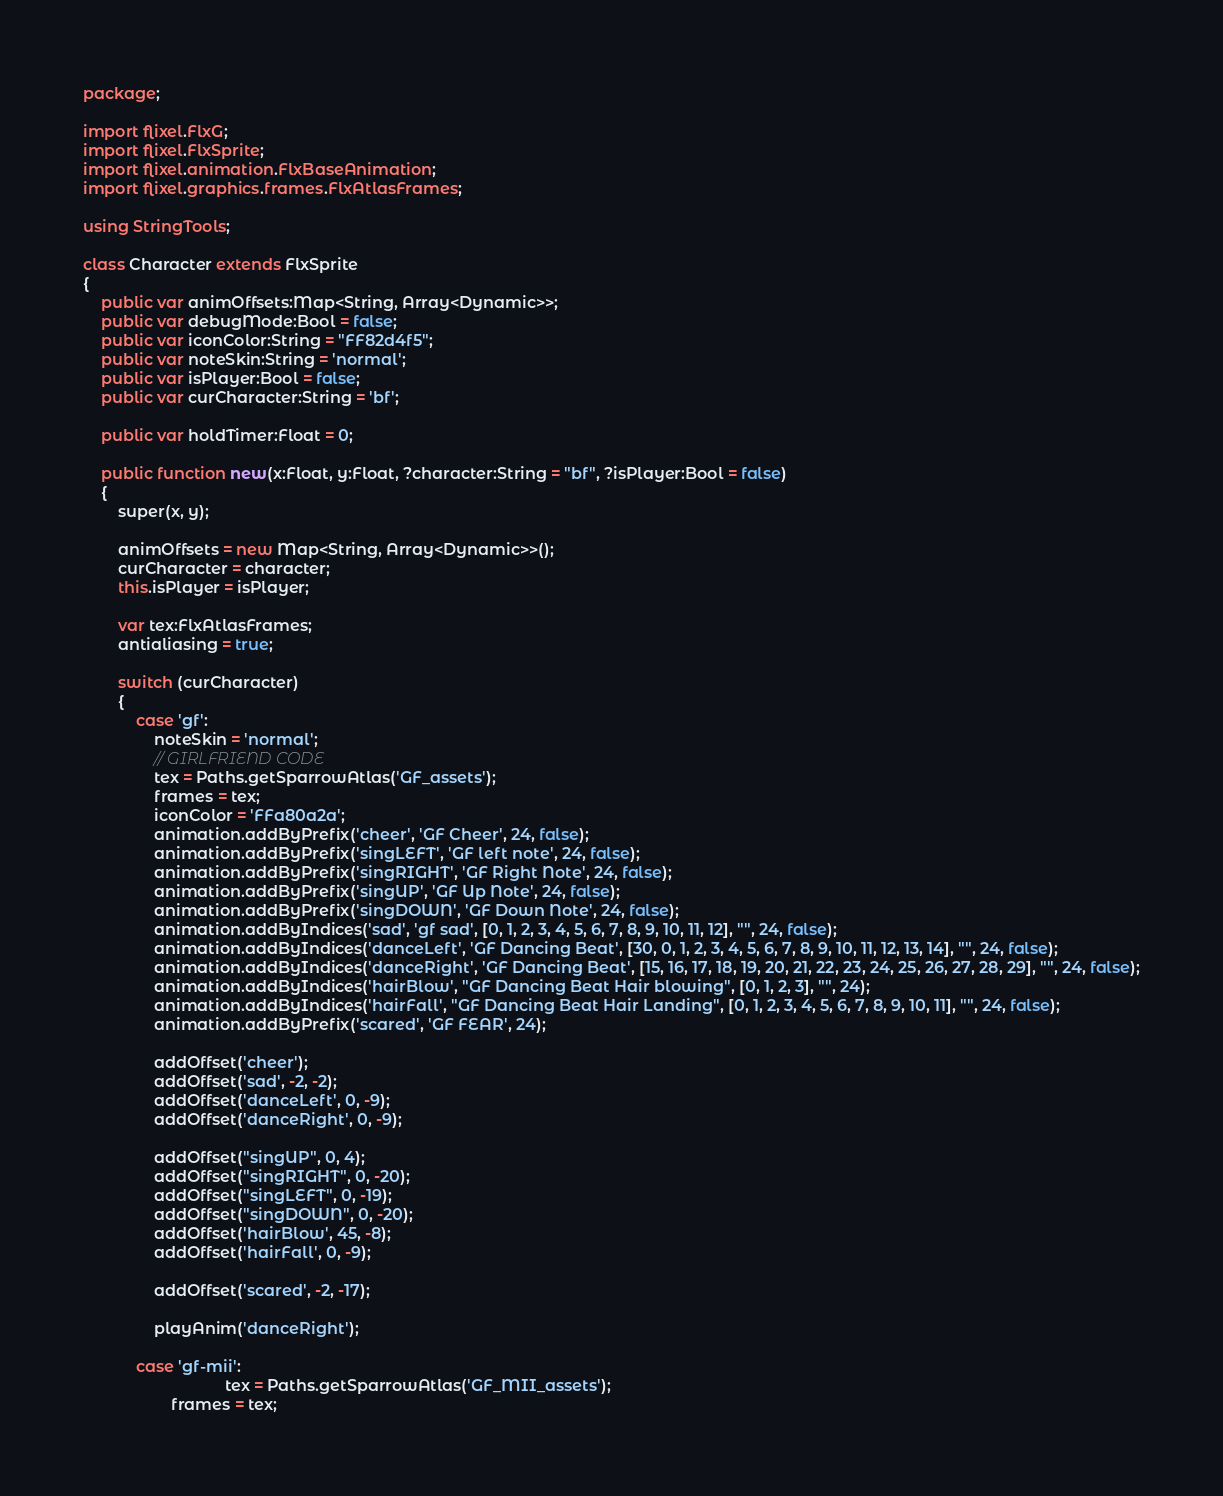<code> <loc_0><loc_0><loc_500><loc_500><_Haxe_>package;

import flixel.FlxG;
import flixel.FlxSprite;
import flixel.animation.FlxBaseAnimation;
import flixel.graphics.frames.FlxAtlasFrames;

using StringTools;

class Character extends FlxSprite
{
	public var animOffsets:Map<String, Array<Dynamic>>;
	public var debugMode:Bool = false;
	public var iconColor:String = "FF82d4f5";
	public var noteSkin:String = 'normal';
	public var isPlayer:Bool = false;
	public var curCharacter:String = 'bf';

	public var holdTimer:Float = 0;

	public function new(x:Float, y:Float, ?character:String = "bf", ?isPlayer:Bool = false)
	{
		super(x, y);

		animOffsets = new Map<String, Array<Dynamic>>();
		curCharacter = character;
		this.isPlayer = isPlayer;

		var tex:FlxAtlasFrames;
		antialiasing = true;

		switch (curCharacter)
		{
			case 'gf':
				noteSkin = 'normal';
				// GIRLFRIEND CODE
				tex = Paths.getSparrowAtlas('GF_assets');
				frames = tex;
				iconColor = 'FFa80a2a';
				animation.addByPrefix('cheer', 'GF Cheer', 24, false);
				animation.addByPrefix('singLEFT', 'GF left note', 24, false);
				animation.addByPrefix('singRIGHT', 'GF Right Note', 24, false);
				animation.addByPrefix('singUP', 'GF Up Note', 24, false);
				animation.addByPrefix('singDOWN', 'GF Down Note', 24, false);
				animation.addByIndices('sad', 'gf sad', [0, 1, 2, 3, 4, 5, 6, 7, 8, 9, 10, 11, 12], "", 24, false);
				animation.addByIndices('danceLeft', 'GF Dancing Beat', [30, 0, 1, 2, 3, 4, 5, 6, 7, 8, 9, 10, 11, 12, 13, 14], "", 24, false);
				animation.addByIndices('danceRight', 'GF Dancing Beat', [15, 16, 17, 18, 19, 20, 21, 22, 23, 24, 25, 26, 27, 28, 29], "", 24, false);
				animation.addByIndices('hairBlow', "GF Dancing Beat Hair blowing", [0, 1, 2, 3], "", 24);
				animation.addByIndices('hairFall', "GF Dancing Beat Hair Landing", [0, 1, 2, 3, 4, 5, 6, 7, 8, 9, 10, 11], "", 24, false);
				animation.addByPrefix('scared', 'GF FEAR', 24);

				addOffset('cheer');
				addOffset('sad', -2, -2);
				addOffset('danceLeft', 0, -9);
				addOffset('danceRight', 0, -9);

				addOffset("singUP", 0, 4);
				addOffset("singRIGHT", 0, -20);
				addOffset("singLEFT", 0, -19);
				addOffset("singDOWN", 0, -20);
				addOffset('hairBlow', 45, -8);
				addOffset('hairFall', 0, -9);

				addOffset('scared', -2, -17);

				playAnim('danceRight');

			case 'gf-mii':
								tex = Paths.getSparrowAtlas('GF_MII_assets');
					frames = tex;</code> 